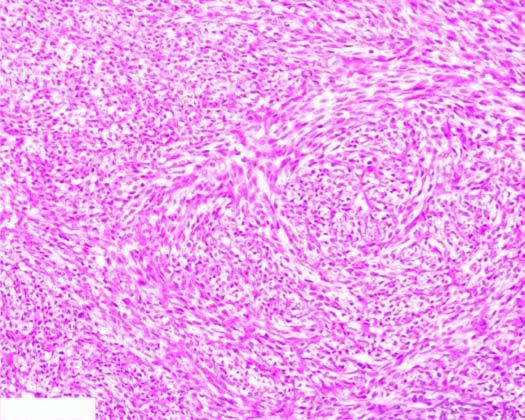what are the tumour cells arranged in?
Answer the question using a single word or phrase. Storiform or cartwheel pattern 